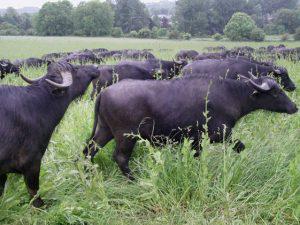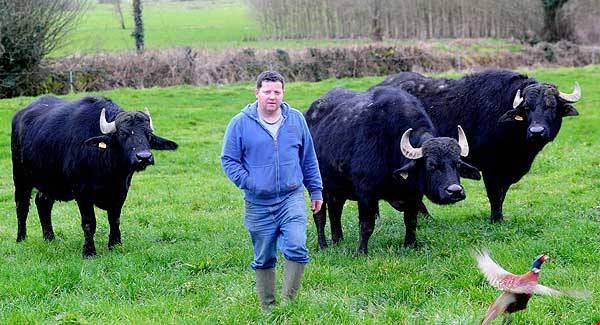The first image is the image on the left, the second image is the image on the right. For the images shown, is this caption "The left image contains only very dark hooved animals surrounded by bright green grass, with the foreground animals facing directly forward." true? Answer yes or no. No. The first image is the image on the left, the second image is the image on the right. Assess this claim about the two images: "In one image there are at least three standing water buffaloes where one is facing a different direction than the others.". Correct or not? Answer yes or no. No. 